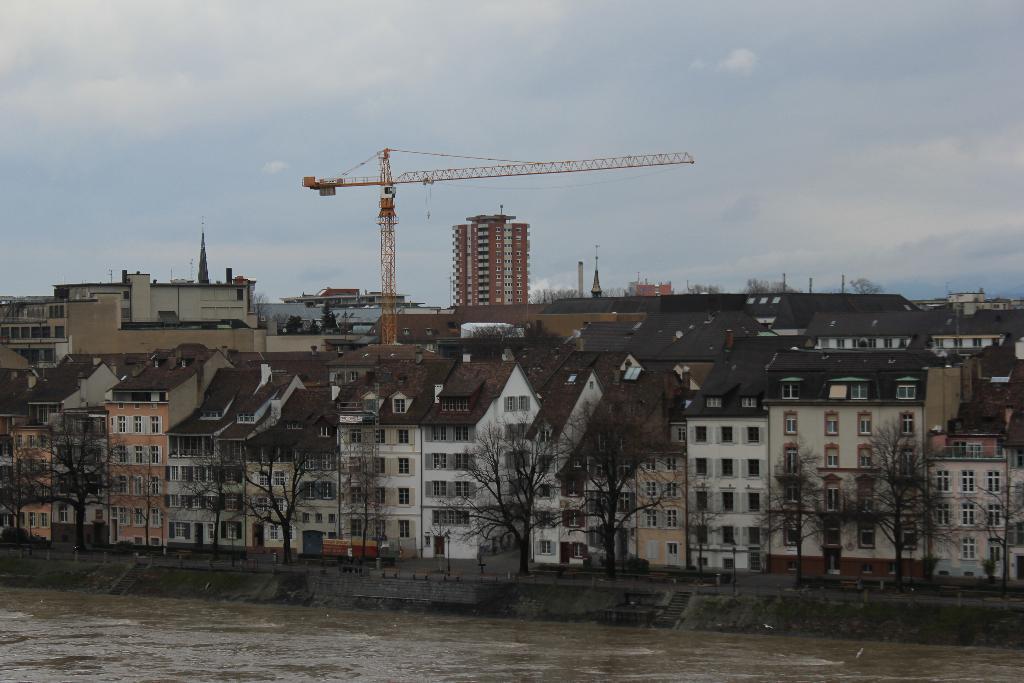In one or two sentences, can you explain what this image depicts? In this image we can see water, road, benches, trash bins, trees, buildings, construction crane and sky with clouds. 